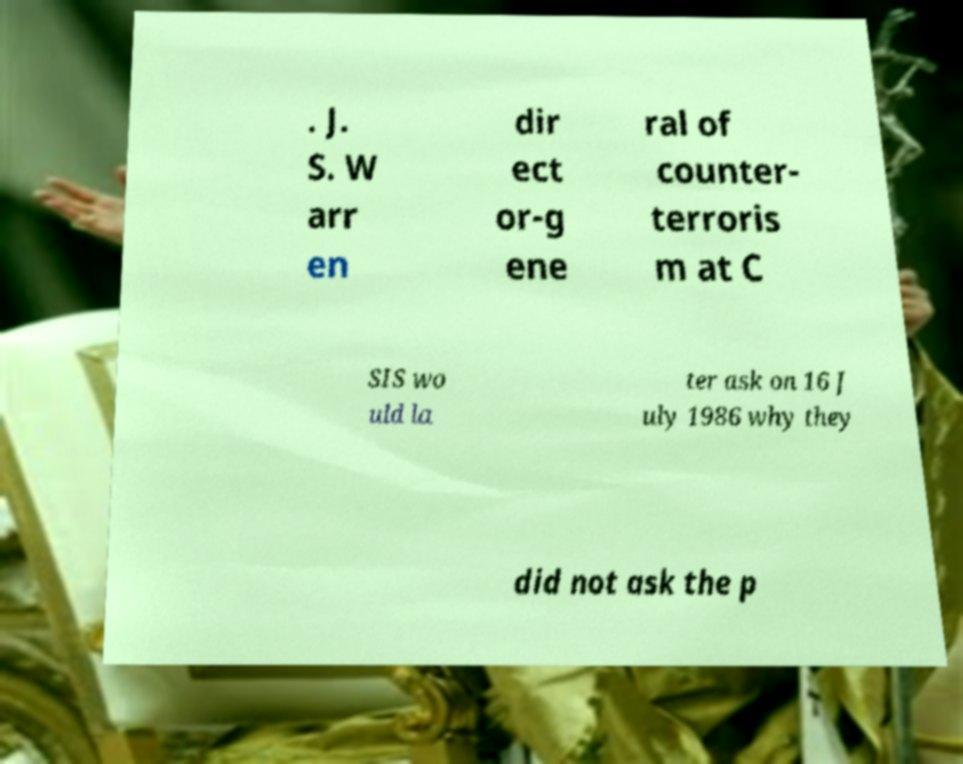Can you read and provide the text displayed in the image?This photo seems to have some interesting text. Can you extract and type it out for me? . J. S. W arr en dir ect or-g ene ral of counter- terroris m at C SIS wo uld la ter ask on 16 J uly 1986 why they did not ask the p 